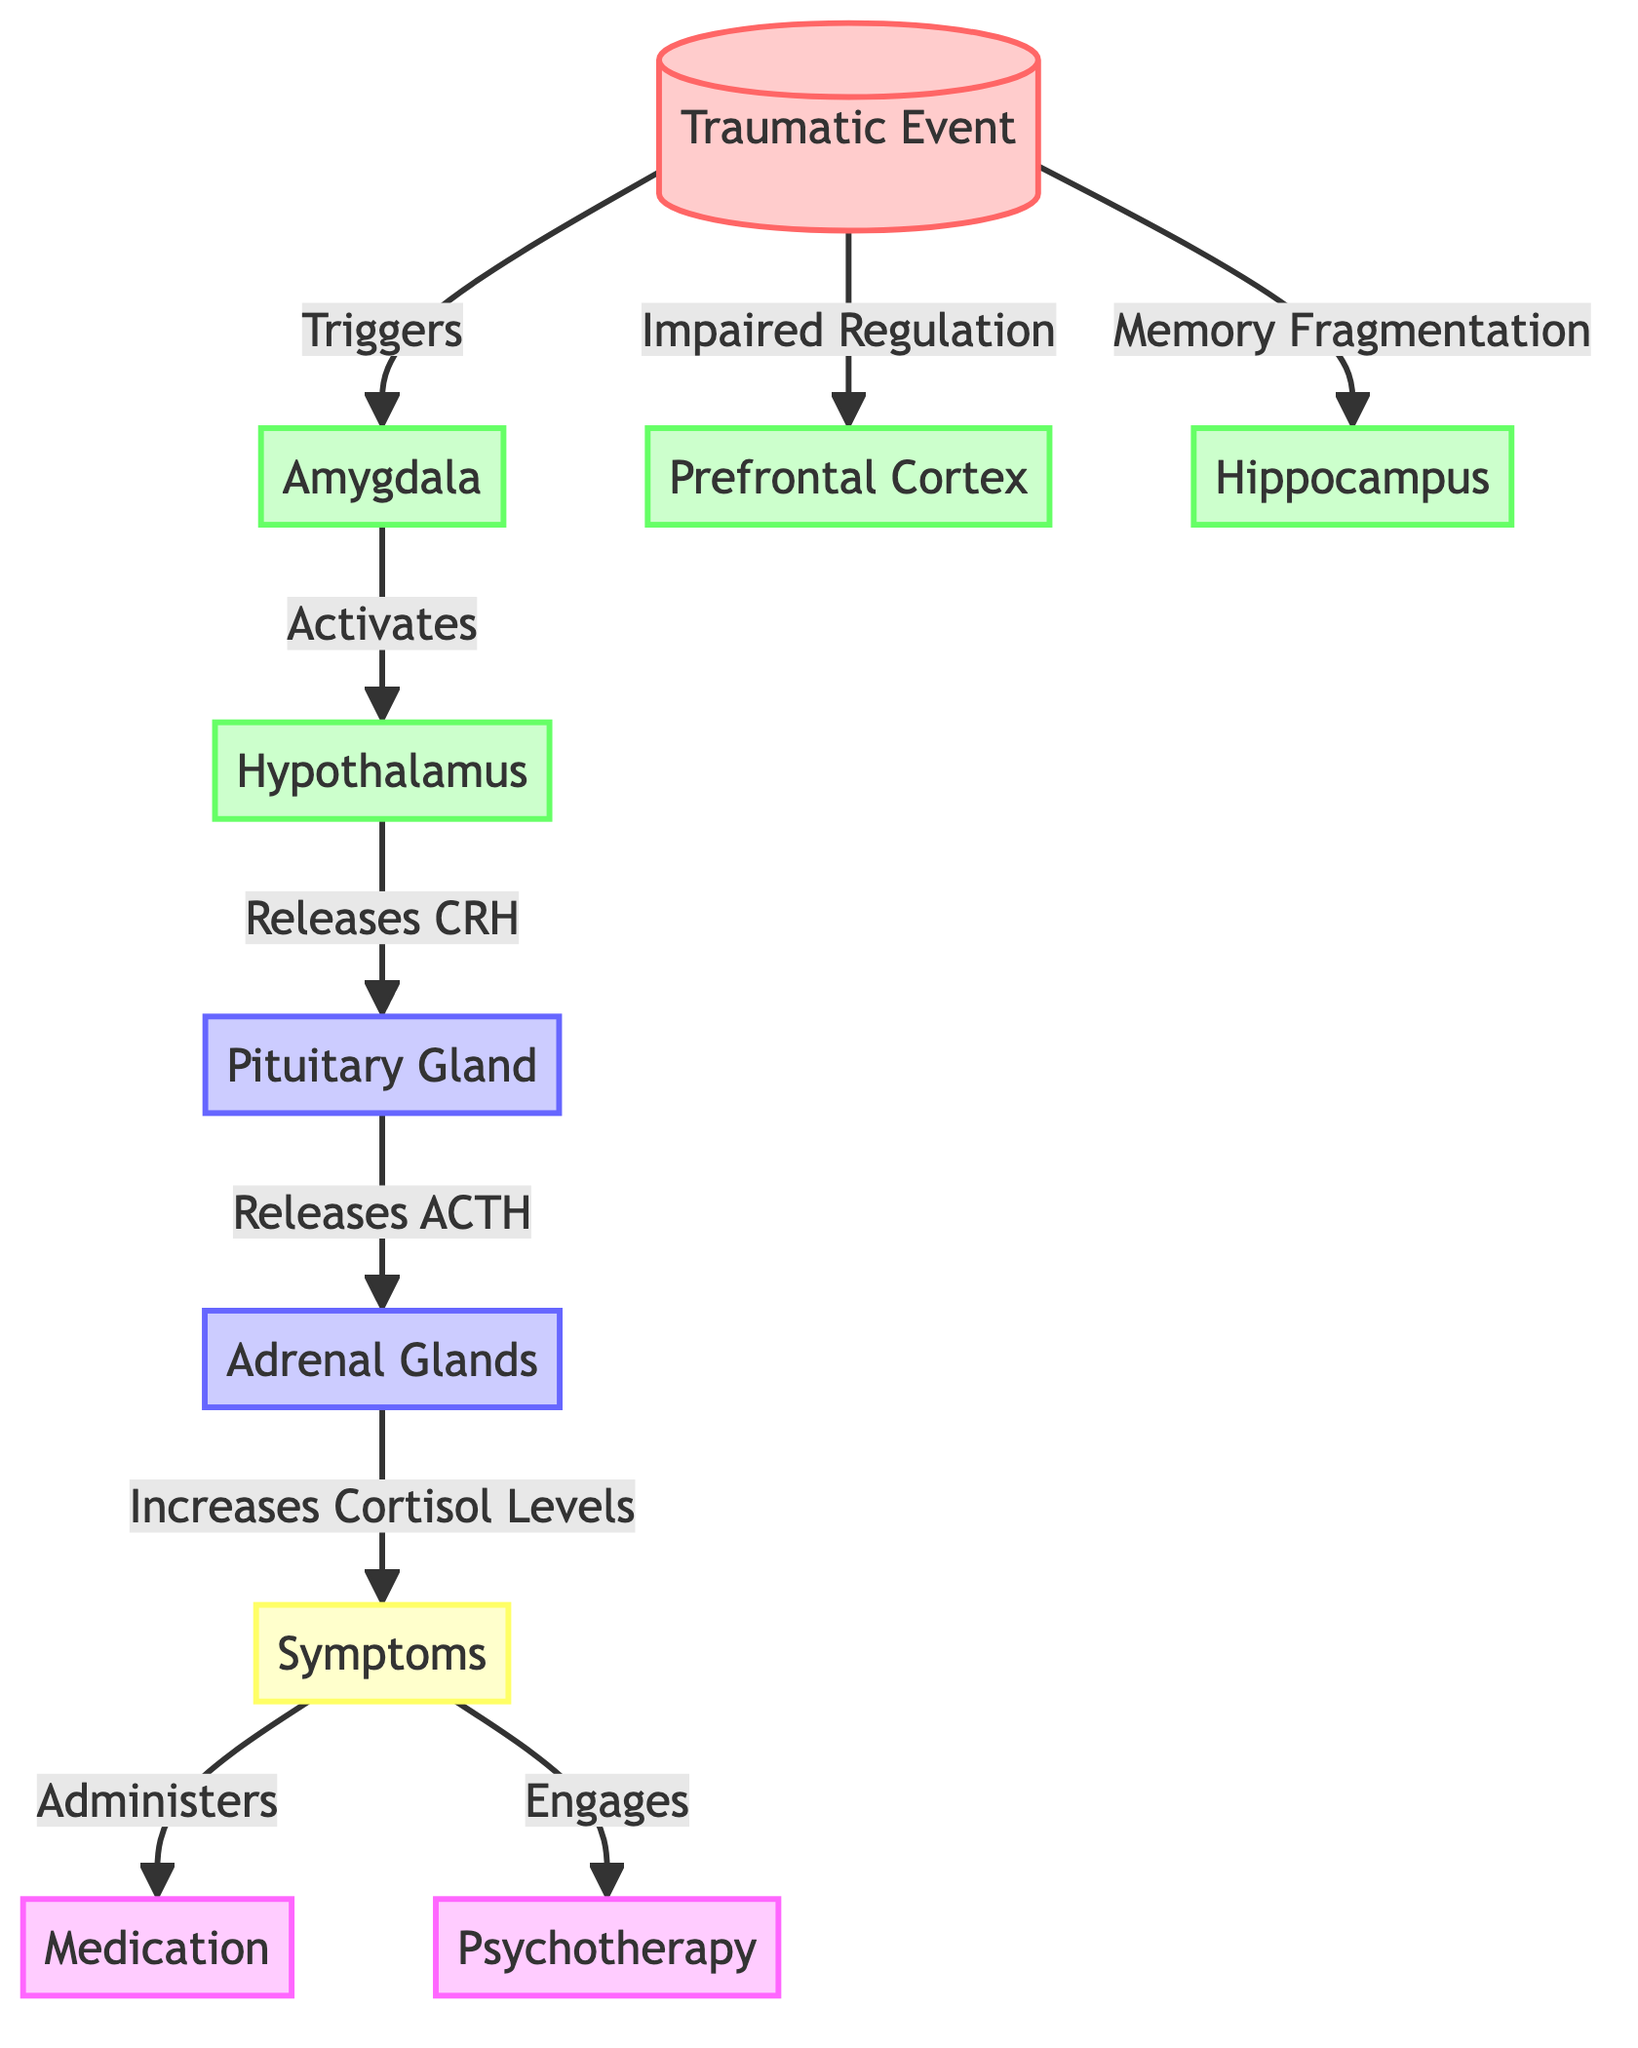What's the first node in the diagram? The first node in the diagram represents the starting point and is labeled as "Traumatic Event". This can be seen clearly at the top of the flowchart.
Answer: Traumatic Event How many brain structures are shown in the diagram? The diagram includes four brain structures, which are the Amygdala, Prefrontal Cortex, Hippocampus, and Hypothalamus. Counting these nodes gives a total of four.
Answer: 4 What hormone is released by the Pituitary Gland? The diagram indicates that the Pituitary Gland releases ACTH. This can be followed from the flow arrows connected from the Hypothalamus to the Pituitary Gland, where the CRH causes the release of ACTH.
Answer: ACTH Which gland increases cortisol levels? The diagram specifies that the Adrenal Glands increase cortisol levels in response to ACTH released by the Pituitary Gland. This relationship shows the hormonal interaction outlined in the diagram.
Answer: Adrenal Glands What symptom results from increased cortisol levels? Increased cortisol levels lead to symptoms that are represented collectively by the node labeled "Symptoms". This node is connected to the Adrenal Glands and indicates the outcomes of hormonal changes.
Answer: Symptoms What therapeutic interventions are shown in the diagram? The diagram presents two therapeutic interventions: Medication and Psychotherapy. Both of these interventions are linked to the node indicating Symptoms, showing potential treatments.
Answer: Medication, Psychotherapy What activates the Hypothalamus? The activation of the Hypothalamus is triggered by the Amygdala, as depicted by the arrow showing that the Amygdala activates the Hypothalamus in the diagram.
Answer: Amygdala Which brain structure is associated with memory fragmentation? The Hippocampus is the brain structure associated with memory fragmentation, clearly stated in the connection shown from the "Traumatic Event" node to the Hippocampus node.
Answer: Hippocampus What does CRH released by the Hypothalamus lead to? CRH released by the Hypothalamus leads to the release of ACTH by the Pituitary Gland, as shown in the diagram. This reflects how hormonal signaling occurs after the traumatic event is processed.
Answer: ACTH 